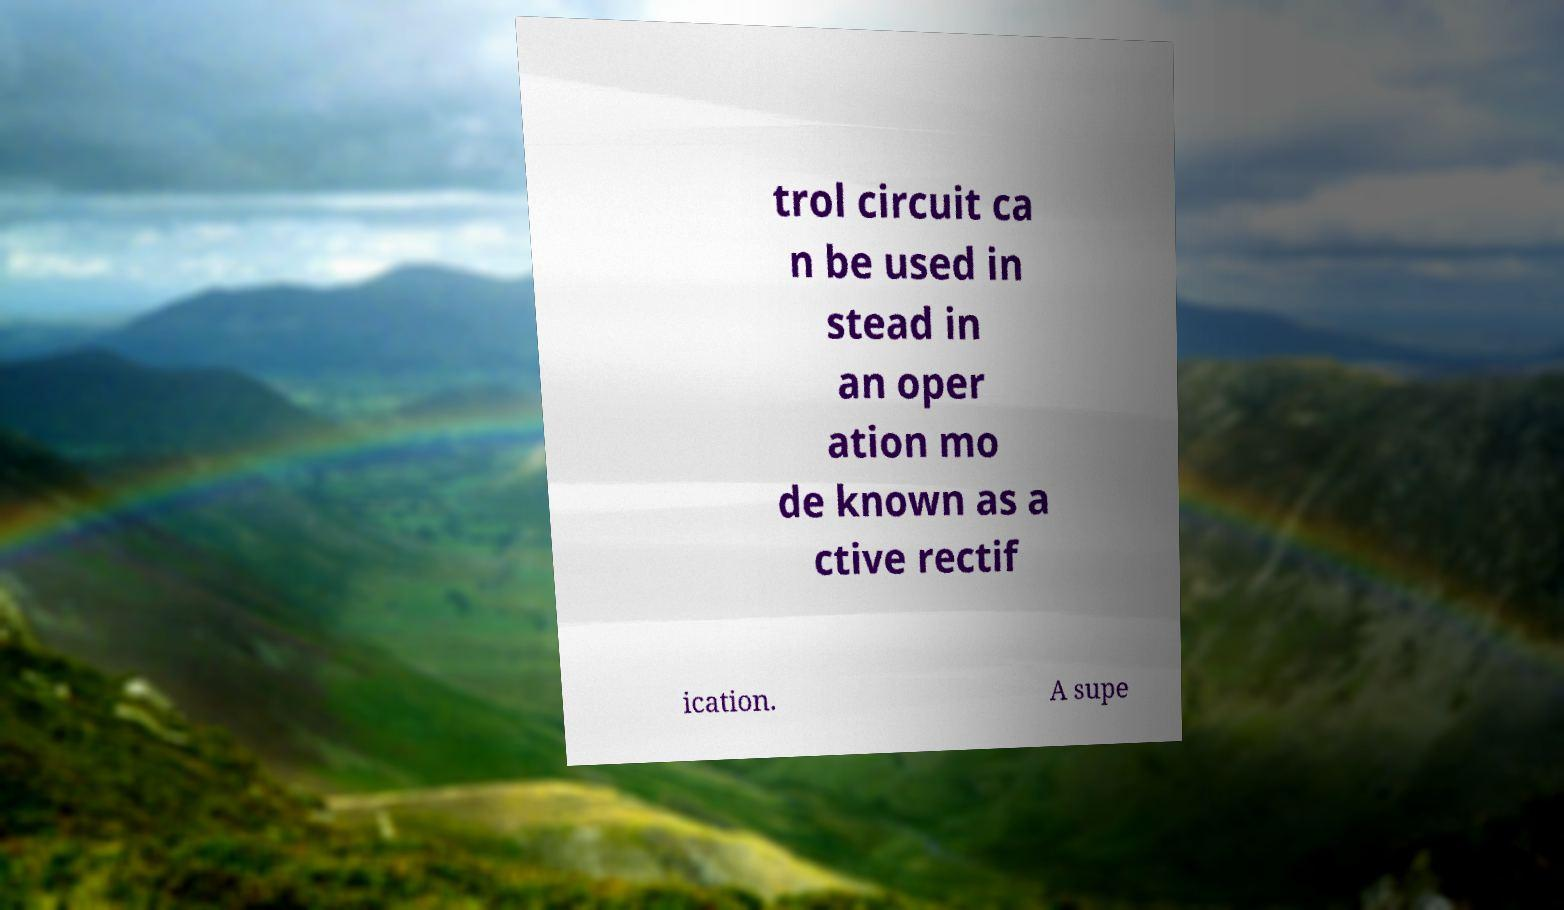Please read and relay the text visible in this image. What does it say? trol circuit ca n be used in stead in an oper ation mo de known as a ctive rectif ication. A supe 